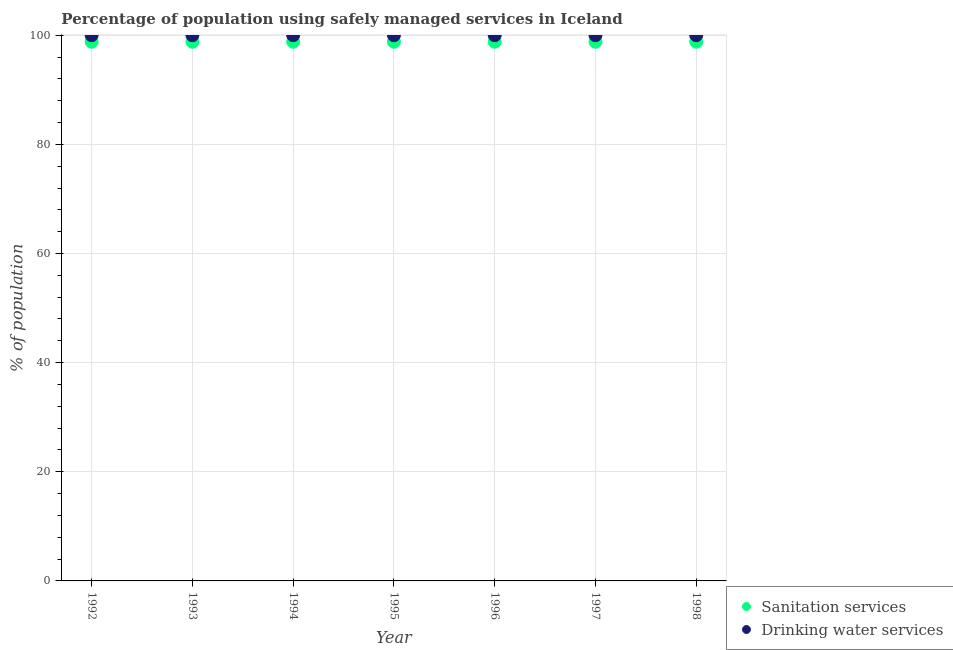Is the number of dotlines equal to the number of legend labels?
Ensure brevity in your answer.  Yes. What is the percentage of population who used drinking water services in 1997?
Provide a short and direct response. 100. Across all years, what is the maximum percentage of population who used drinking water services?
Ensure brevity in your answer.  100. Across all years, what is the minimum percentage of population who used sanitation services?
Offer a terse response. 98.8. In which year was the percentage of population who used drinking water services minimum?
Ensure brevity in your answer.  1992. What is the total percentage of population who used sanitation services in the graph?
Ensure brevity in your answer.  691.6. What is the difference between the percentage of population who used drinking water services in 1994 and the percentage of population who used sanitation services in 1996?
Offer a terse response. 1.2. In the year 1995, what is the difference between the percentage of population who used drinking water services and percentage of population who used sanitation services?
Offer a terse response. 1.2. In how many years, is the percentage of population who used sanitation services greater than 12 %?
Provide a short and direct response. 7. Is the percentage of population who used drinking water services in 1993 less than that in 1998?
Provide a short and direct response. No. Is the difference between the percentage of population who used drinking water services in 1993 and 1994 greater than the difference between the percentage of population who used sanitation services in 1993 and 1994?
Keep it short and to the point. No. What is the difference between the highest and the second highest percentage of population who used drinking water services?
Your response must be concise. 0. What is the difference between the highest and the lowest percentage of population who used sanitation services?
Offer a terse response. 0. In how many years, is the percentage of population who used sanitation services greater than the average percentage of population who used sanitation services taken over all years?
Keep it short and to the point. 7. Is the sum of the percentage of population who used sanitation services in 1993 and 1997 greater than the maximum percentage of population who used drinking water services across all years?
Your answer should be compact. Yes. How many years are there in the graph?
Keep it short and to the point. 7. What is the difference between two consecutive major ticks on the Y-axis?
Your answer should be very brief. 20. Does the graph contain any zero values?
Make the answer very short. No. How many legend labels are there?
Offer a terse response. 2. What is the title of the graph?
Your answer should be very brief. Percentage of population using safely managed services in Iceland. Does "Lower secondary education" appear as one of the legend labels in the graph?
Make the answer very short. No. What is the label or title of the X-axis?
Your answer should be compact. Year. What is the label or title of the Y-axis?
Keep it short and to the point. % of population. What is the % of population of Sanitation services in 1992?
Your answer should be compact. 98.8. What is the % of population in Drinking water services in 1992?
Provide a succinct answer. 100. What is the % of population of Sanitation services in 1993?
Your answer should be compact. 98.8. What is the % of population in Drinking water services in 1993?
Make the answer very short. 100. What is the % of population in Sanitation services in 1994?
Provide a short and direct response. 98.8. What is the % of population of Sanitation services in 1995?
Your response must be concise. 98.8. What is the % of population of Sanitation services in 1996?
Offer a terse response. 98.8. What is the % of population in Drinking water services in 1996?
Offer a terse response. 100. What is the % of population of Sanitation services in 1997?
Your answer should be very brief. 98.8. What is the % of population in Drinking water services in 1997?
Give a very brief answer. 100. What is the % of population in Sanitation services in 1998?
Your answer should be compact. 98.8. What is the % of population of Drinking water services in 1998?
Ensure brevity in your answer.  100. Across all years, what is the maximum % of population of Sanitation services?
Offer a very short reply. 98.8. Across all years, what is the minimum % of population of Sanitation services?
Keep it short and to the point. 98.8. Across all years, what is the minimum % of population of Drinking water services?
Your answer should be very brief. 100. What is the total % of population in Sanitation services in the graph?
Ensure brevity in your answer.  691.6. What is the total % of population of Drinking water services in the graph?
Ensure brevity in your answer.  700. What is the difference between the % of population of Sanitation services in 1992 and that in 1993?
Provide a succinct answer. 0. What is the difference between the % of population of Drinking water services in 1992 and that in 1994?
Give a very brief answer. 0. What is the difference between the % of population of Sanitation services in 1992 and that in 1995?
Provide a succinct answer. 0. What is the difference between the % of population of Drinking water services in 1992 and that in 1995?
Keep it short and to the point. 0. What is the difference between the % of population in Sanitation services in 1992 and that in 1996?
Offer a very short reply. 0. What is the difference between the % of population in Drinking water services in 1992 and that in 1996?
Offer a very short reply. 0. What is the difference between the % of population in Sanitation services in 1992 and that in 1997?
Provide a succinct answer. 0. What is the difference between the % of population in Sanitation services in 1992 and that in 1998?
Your answer should be compact. 0. What is the difference between the % of population in Sanitation services in 1993 and that in 1995?
Make the answer very short. 0. What is the difference between the % of population in Drinking water services in 1993 and that in 1995?
Your answer should be compact. 0. What is the difference between the % of population in Sanitation services in 1993 and that in 1996?
Your response must be concise. 0. What is the difference between the % of population of Drinking water services in 1993 and that in 1996?
Your answer should be compact. 0. What is the difference between the % of population in Sanitation services in 1993 and that in 1997?
Provide a succinct answer. 0. What is the difference between the % of population of Sanitation services in 1993 and that in 1998?
Ensure brevity in your answer.  0. What is the difference between the % of population of Drinking water services in 1993 and that in 1998?
Keep it short and to the point. 0. What is the difference between the % of population in Drinking water services in 1994 and that in 1996?
Your answer should be compact. 0. What is the difference between the % of population of Drinking water services in 1994 and that in 1997?
Give a very brief answer. 0. What is the difference between the % of population in Sanitation services in 1994 and that in 1998?
Offer a very short reply. 0. What is the difference between the % of population of Sanitation services in 1995 and that in 1996?
Provide a short and direct response. 0. What is the difference between the % of population of Drinking water services in 1995 and that in 1996?
Provide a succinct answer. 0. What is the difference between the % of population in Sanitation services in 1995 and that in 1997?
Offer a very short reply. 0. What is the difference between the % of population of Drinking water services in 1995 and that in 1998?
Provide a succinct answer. 0. What is the difference between the % of population in Drinking water services in 1996 and that in 1997?
Give a very brief answer. 0. What is the difference between the % of population in Sanitation services in 1996 and that in 1998?
Your answer should be compact. 0. What is the difference between the % of population in Sanitation services in 1997 and that in 1998?
Your answer should be compact. 0. What is the difference between the % of population in Sanitation services in 1992 and the % of population in Drinking water services in 1994?
Your answer should be very brief. -1.2. What is the difference between the % of population in Sanitation services in 1992 and the % of population in Drinking water services in 1998?
Offer a terse response. -1.2. What is the difference between the % of population of Sanitation services in 1993 and the % of population of Drinking water services in 1995?
Provide a short and direct response. -1.2. What is the difference between the % of population of Sanitation services in 1993 and the % of population of Drinking water services in 1996?
Offer a very short reply. -1.2. What is the difference between the % of population of Sanitation services in 1994 and the % of population of Drinking water services in 1995?
Offer a very short reply. -1.2. What is the difference between the % of population of Sanitation services in 1994 and the % of population of Drinking water services in 1996?
Provide a short and direct response. -1.2. What is the difference between the % of population in Sanitation services in 1994 and the % of population in Drinking water services in 1997?
Your answer should be very brief. -1.2. What is the difference between the % of population in Sanitation services in 1994 and the % of population in Drinking water services in 1998?
Provide a short and direct response. -1.2. What is the difference between the % of population in Sanitation services in 1995 and the % of population in Drinking water services in 1997?
Offer a terse response. -1.2. What is the difference between the % of population of Sanitation services in 1996 and the % of population of Drinking water services in 1998?
Your answer should be compact. -1.2. What is the difference between the % of population of Sanitation services in 1997 and the % of population of Drinking water services in 1998?
Provide a short and direct response. -1.2. What is the average % of population in Sanitation services per year?
Give a very brief answer. 98.8. In the year 1993, what is the difference between the % of population of Sanitation services and % of population of Drinking water services?
Keep it short and to the point. -1.2. In the year 1996, what is the difference between the % of population in Sanitation services and % of population in Drinking water services?
Your answer should be compact. -1.2. What is the ratio of the % of population in Sanitation services in 1992 to that in 1993?
Offer a terse response. 1. What is the ratio of the % of population in Sanitation services in 1992 to that in 1994?
Your response must be concise. 1. What is the ratio of the % of population of Sanitation services in 1992 to that in 1997?
Your answer should be very brief. 1. What is the ratio of the % of population in Drinking water services in 1992 to that in 1997?
Keep it short and to the point. 1. What is the ratio of the % of population in Drinking water services in 1992 to that in 1998?
Provide a short and direct response. 1. What is the ratio of the % of population in Sanitation services in 1993 to that in 1994?
Offer a very short reply. 1. What is the ratio of the % of population in Drinking water services in 1993 to that in 1994?
Offer a very short reply. 1. What is the ratio of the % of population in Sanitation services in 1993 to that in 1995?
Ensure brevity in your answer.  1. What is the ratio of the % of population of Sanitation services in 1993 to that in 1997?
Provide a succinct answer. 1. What is the ratio of the % of population in Drinking water services in 1993 to that in 1997?
Make the answer very short. 1. What is the ratio of the % of population of Drinking water services in 1993 to that in 1998?
Your answer should be very brief. 1. What is the ratio of the % of population in Sanitation services in 1994 to that in 1995?
Provide a short and direct response. 1. What is the ratio of the % of population of Sanitation services in 1994 to that in 1996?
Your answer should be compact. 1. What is the ratio of the % of population of Drinking water services in 1994 to that in 1996?
Provide a short and direct response. 1. What is the ratio of the % of population in Sanitation services in 1994 to that in 1997?
Keep it short and to the point. 1. What is the ratio of the % of population of Drinking water services in 1994 to that in 1998?
Provide a succinct answer. 1. What is the ratio of the % of population of Drinking water services in 1995 to that in 1996?
Offer a terse response. 1. What is the ratio of the % of population of Sanitation services in 1995 to that in 1997?
Your response must be concise. 1. What is the ratio of the % of population of Drinking water services in 1995 to that in 1997?
Your answer should be compact. 1. What is the ratio of the % of population of Sanitation services in 1995 to that in 1998?
Provide a short and direct response. 1. What is the ratio of the % of population of Drinking water services in 1996 to that in 1998?
Keep it short and to the point. 1. What is the ratio of the % of population of Sanitation services in 1997 to that in 1998?
Ensure brevity in your answer.  1. What is the difference between the highest and the second highest % of population of Sanitation services?
Your response must be concise. 0. What is the difference between the highest and the second highest % of population of Drinking water services?
Your answer should be very brief. 0. What is the difference between the highest and the lowest % of population in Sanitation services?
Make the answer very short. 0. 